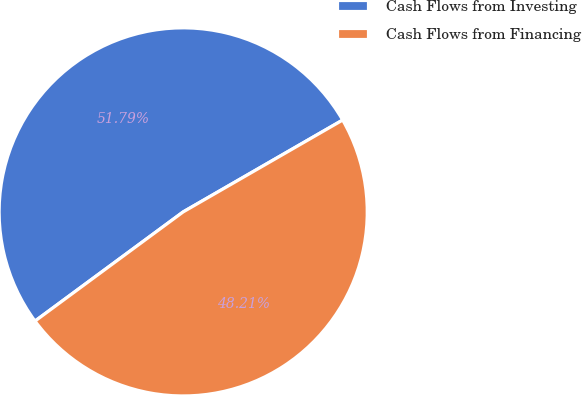Convert chart to OTSL. <chart><loc_0><loc_0><loc_500><loc_500><pie_chart><fcel>Cash Flows from Investing<fcel>Cash Flows from Financing<nl><fcel>51.79%<fcel>48.21%<nl></chart> 